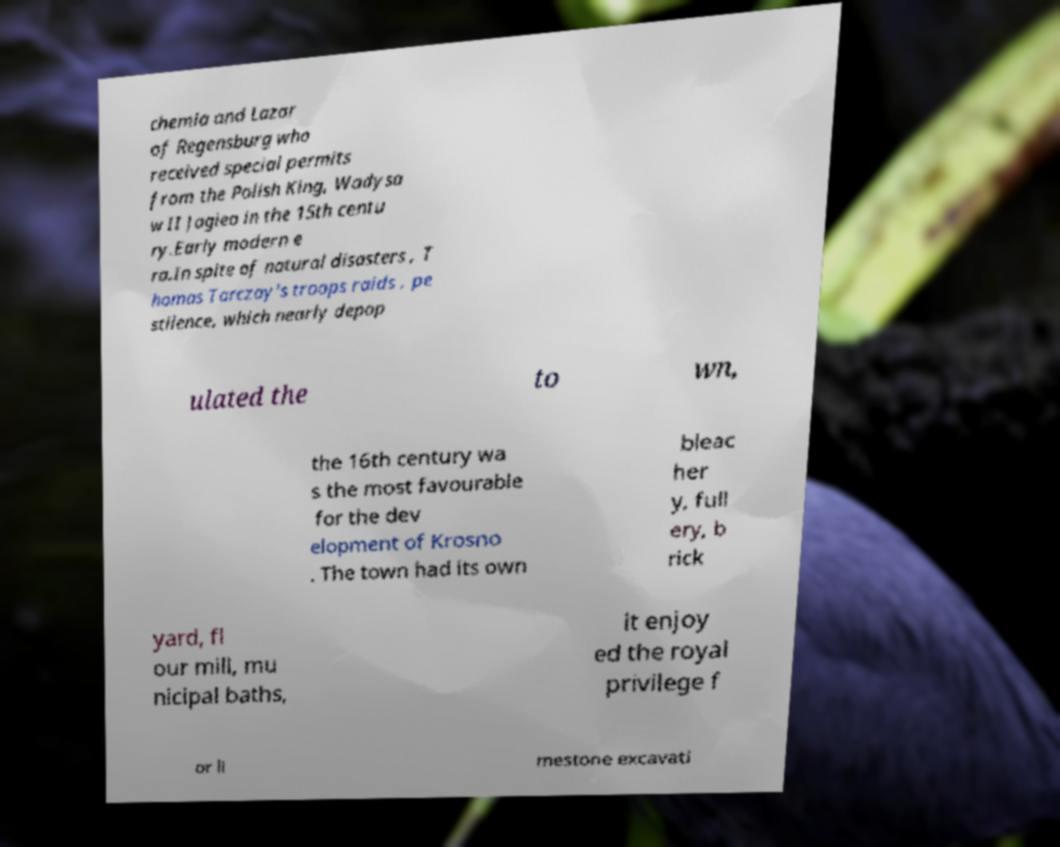I need the written content from this picture converted into text. Can you do that? chemia and Lazar of Regensburg who received special permits from the Polish King, Wadysa w II Jagieo in the 15th centu ry.Early modern e ra.In spite of natural disasters , T homas Tarczay's troops raids , pe stilence, which nearly depop ulated the to wn, the 16th century wa s the most favourable for the dev elopment of Krosno . The town had its own bleac her y, full ery, b rick yard, fl our mill, mu nicipal baths, it enjoy ed the royal privilege f or li mestone excavati 